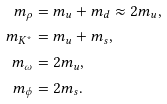<formula> <loc_0><loc_0><loc_500><loc_500>m _ { \rho } & = m _ { u } + m _ { d } \approx 2 m _ { u } , \\ m _ { K ^ { * } } & = m _ { u } + m _ { s } , \\ m _ { \omega } & = 2 m _ { u } , \\ m _ { \phi } & = 2 m _ { s } .</formula> 